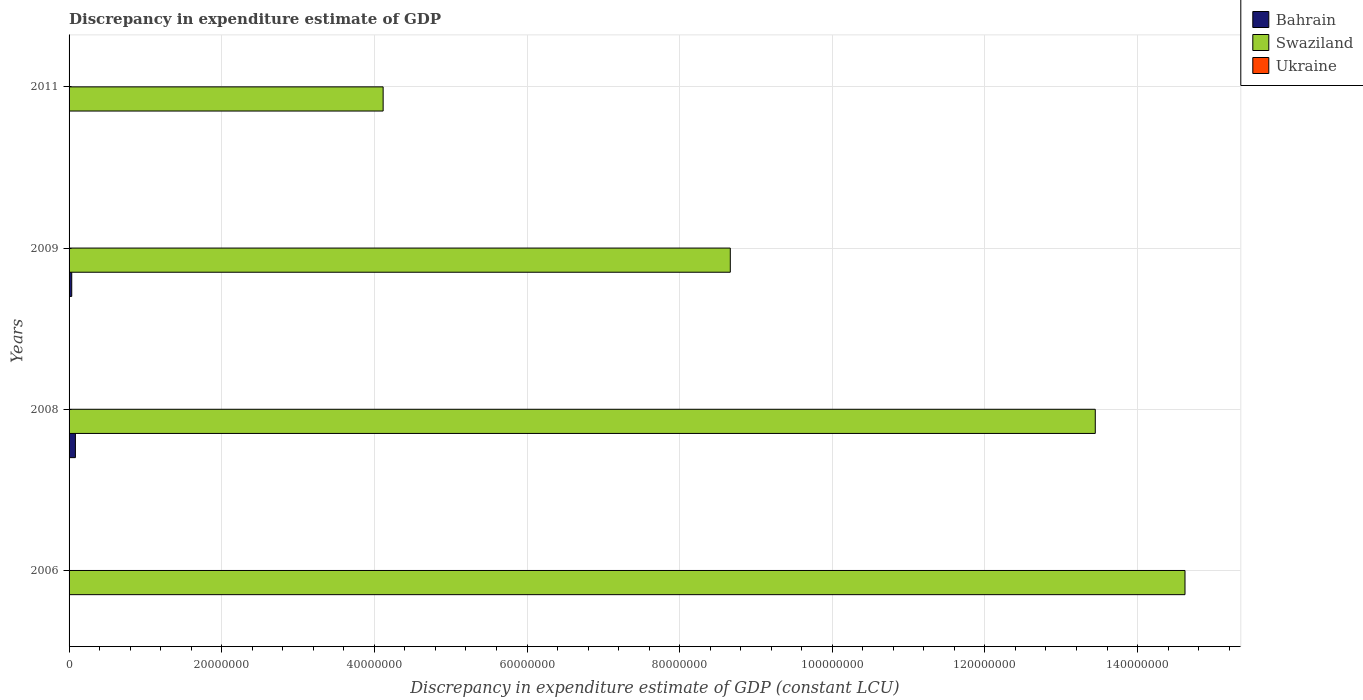How many groups of bars are there?
Your answer should be compact. 4. Are the number of bars on each tick of the Y-axis equal?
Your response must be concise. Yes. How many bars are there on the 3rd tick from the bottom?
Keep it short and to the point. 2. What is the label of the 4th group of bars from the top?
Provide a succinct answer. 2006. What is the discrepancy in expenditure estimate of GDP in Swaziland in 2006?
Make the answer very short. 1.46e+08. Across all years, what is the maximum discrepancy in expenditure estimate of GDP in Bahrain?
Your response must be concise. 8.30e+05. Across all years, what is the minimum discrepancy in expenditure estimate of GDP in Ukraine?
Ensure brevity in your answer.  0. In which year was the discrepancy in expenditure estimate of GDP in Bahrain maximum?
Your response must be concise. 2008. What is the total discrepancy in expenditure estimate of GDP in Swaziland in the graph?
Your answer should be very brief. 4.08e+08. What is the difference between the discrepancy in expenditure estimate of GDP in Swaziland in 2008 and that in 2011?
Your response must be concise. 9.33e+07. What is the difference between the discrepancy in expenditure estimate of GDP in Bahrain in 2006 and the discrepancy in expenditure estimate of GDP in Swaziland in 2011?
Provide a short and direct response. -4.11e+07. What is the average discrepancy in expenditure estimate of GDP in Swaziland per year?
Make the answer very short. 1.02e+08. In the year 2011, what is the difference between the discrepancy in expenditure estimate of GDP in Swaziland and discrepancy in expenditure estimate of GDP in Bahrain?
Your answer should be compact. 4.11e+07. What is the ratio of the discrepancy in expenditure estimate of GDP in Bahrain in 2008 to that in 2009?
Provide a succinct answer. 2.37. Is the discrepancy in expenditure estimate of GDP in Swaziland in 2009 less than that in 2011?
Offer a terse response. No. What is the difference between the highest and the second highest discrepancy in expenditure estimate of GDP in Swaziland?
Your answer should be very brief. 1.18e+07. Is the sum of the discrepancy in expenditure estimate of GDP in Bahrain in 2006 and 2008 greater than the maximum discrepancy in expenditure estimate of GDP in Ukraine across all years?
Your answer should be compact. Yes. Is it the case that in every year, the sum of the discrepancy in expenditure estimate of GDP in Bahrain and discrepancy in expenditure estimate of GDP in Ukraine is greater than the discrepancy in expenditure estimate of GDP in Swaziland?
Ensure brevity in your answer.  No. Are all the bars in the graph horizontal?
Ensure brevity in your answer.  Yes. How many years are there in the graph?
Keep it short and to the point. 4. What is the difference between two consecutive major ticks on the X-axis?
Ensure brevity in your answer.  2.00e+07. What is the title of the graph?
Provide a short and direct response. Discrepancy in expenditure estimate of GDP. What is the label or title of the X-axis?
Ensure brevity in your answer.  Discrepancy in expenditure estimate of GDP (constant LCU). What is the label or title of the Y-axis?
Your answer should be compact. Years. What is the Discrepancy in expenditure estimate of GDP (constant LCU) of Bahrain in 2006?
Provide a short and direct response. 10000. What is the Discrepancy in expenditure estimate of GDP (constant LCU) in Swaziland in 2006?
Provide a succinct answer. 1.46e+08. What is the Discrepancy in expenditure estimate of GDP (constant LCU) in Ukraine in 2006?
Make the answer very short. 0. What is the Discrepancy in expenditure estimate of GDP (constant LCU) in Bahrain in 2008?
Provide a succinct answer. 8.30e+05. What is the Discrepancy in expenditure estimate of GDP (constant LCU) of Swaziland in 2008?
Your answer should be very brief. 1.34e+08. What is the Discrepancy in expenditure estimate of GDP (constant LCU) in Swaziland in 2009?
Give a very brief answer. 8.66e+07. What is the Discrepancy in expenditure estimate of GDP (constant LCU) in Swaziland in 2011?
Your answer should be very brief. 4.12e+07. What is the Discrepancy in expenditure estimate of GDP (constant LCU) of Ukraine in 2011?
Ensure brevity in your answer.  0. Across all years, what is the maximum Discrepancy in expenditure estimate of GDP (constant LCU) of Bahrain?
Provide a succinct answer. 8.30e+05. Across all years, what is the maximum Discrepancy in expenditure estimate of GDP (constant LCU) in Swaziland?
Provide a short and direct response. 1.46e+08. Across all years, what is the minimum Discrepancy in expenditure estimate of GDP (constant LCU) in Swaziland?
Offer a very short reply. 4.12e+07. What is the total Discrepancy in expenditure estimate of GDP (constant LCU) in Bahrain in the graph?
Ensure brevity in your answer.  1.24e+06. What is the total Discrepancy in expenditure estimate of GDP (constant LCU) in Swaziland in the graph?
Offer a very short reply. 4.08e+08. What is the total Discrepancy in expenditure estimate of GDP (constant LCU) in Ukraine in the graph?
Make the answer very short. 0. What is the difference between the Discrepancy in expenditure estimate of GDP (constant LCU) in Bahrain in 2006 and that in 2008?
Offer a terse response. -8.20e+05. What is the difference between the Discrepancy in expenditure estimate of GDP (constant LCU) in Swaziland in 2006 and that in 2008?
Give a very brief answer. 1.18e+07. What is the difference between the Discrepancy in expenditure estimate of GDP (constant LCU) in Bahrain in 2006 and that in 2009?
Offer a terse response. -3.40e+05. What is the difference between the Discrepancy in expenditure estimate of GDP (constant LCU) in Swaziland in 2006 and that in 2009?
Ensure brevity in your answer.  5.96e+07. What is the difference between the Discrepancy in expenditure estimate of GDP (constant LCU) in Swaziland in 2006 and that in 2011?
Provide a succinct answer. 1.05e+08. What is the difference between the Discrepancy in expenditure estimate of GDP (constant LCU) in Bahrain in 2008 and that in 2009?
Provide a succinct answer. 4.80e+05. What is the difference between the Discrepancy in expenditure estimate of GDP (constant LCU) of Swaziland in 2008 and that in 2009?
Offer a terse response. 4.78e+07. What is the difference between the Discrepancy in expenditure estimate of GDP (constant LCU) of Bahrain in 2008 and that in 2011?
Keep it short and to the point. 7.80e+05. What is the difference between the Discrepancy in expenditure estimate of GDP (constant LCU) in Swaziland in 2008 and that in 2011?
Your answer should be very brief. 9.33e+07. What is the difference between the Discrepancy in expenditure estimate of GDP (constant LCU) in Swaziland in 2009 and that in 2011?
Your answer should be compact. 4.55e+07. What is the difference between the Discrepancy in expenditure estimate of GDP (constant LCU) of Bahrain in 2006 and the Discrepancy in expenditure estimate of GDP (constant LCU) of Swaziland in 2008?
Your answer should be compact. -1.34e+08. What is the difference between the Discrepancy in expenditure estimate of GDP (constant LCU) of Bahrain in 2006 and the Discrepancy in expenditure estimate of GDP (constant LCU) of Swaziland in 2009?
Give a very brief answer. -8.66e+07. What is the difference between the Discrepancy in expenditure estimate of GDP (constant LCU) of Bahrain in 2006 and the Discrepancy in expenditure estimate of GDP (constant LCU) of Swaziland in 2011?
Ensure brevity in your answer.  -4.11e+07. What is the difference between the Discrepancy in expenditure estimate of GDP (constant LCU) in Bahrain in 2008 and the Discrepancy in expenditure estimate of GDP (constant LCU) in Swaziland in 2009?
Your answer should be very brief. -8.58e+07. What is the difference between the Discrepancy in expenditure estimate of GDP (constant LCU) in Bahrain in 2008 and the Discrepancy in expenditure estimate of GDP (constant LCU) in Swaziland in 2011?
Offer a terse response. -4.03e+07. What is the difference between the Discrepancy in expenditure estimate of GDP (constant LCU) in Bahrain in 2009 and the Discrepancy in expenditure estimate of GDP (constant LCU) in Swaziland in 2011?
Your response must be concise. -4.08e+07. What is the average Discrepancy in expenditure estimate of GDP (constant LCU) in Bahrain per year?
Offer a very short reply. 3.10e+05. What is the average Discrepancy in expenditure estimate of GDP (constant LCU) in Swaziland per year?
Give a very brief answer. 1.02e+08. In the year 2006, what is the difference between the Discrepancy in expenditure estimate of GDP (constant LCU) in Bahrain and Discrepancy in expenditure estimate of GDP (constant LCU) in Swaziland?
Keep it short and to the point. -1.46e+08. In the year 2008, what is the difference between the Discrepancy in expenditure estimate of GDP (constant LCU) of Bahrain and Discrepancy in expenditure estimate of GDP (constant LCU) of Swaziland?
Offer a very short reply. -1.34e+08. In the year 2009, what is the difference between the Discrepancy in expenditure estimate of GDP (constant LCU) in Bahrain and Discrepancy in expenditure estimate of GDP (constant LCU) in Swaziland?
Your answer should be compact. -8.63e+07. In the year 2011, what is the difference between the Discrepancy in expenditure estimate of GDP (constant LCU) in Bahrain and Discrepancy in expenditure estimate of GDP (constant LCU) in Swaziland?
Your answer should be very brief. -4.11e+07. What is the ratio of the Discrepancy in expenditure estimate of GDP (constant LCU) of Bahrain in 2006 to that in 2008?
Provide a short and direct response. 0.01. What is the ratio of the Discrepancy in expenditure estimate of GDP (constant LCU) of Swaziland in 2006 to that in 2008?
Provide a short and direct response. 1.09. What is the ratio of the Discrepancy in expenditure estimate of GDP (constant LCU) in Bahrain in 2006 to that in 2009?
Ensure brevity in your answer.  0.03. What is the ratio of the Discrepancy in expenditure estimate of GDP (constant LCU) in Swaziland in 2006 to that in 2009?
Your answer should be very brief. 1.69. What is the ratio of the Discrepancy in expenditure estimate of GDP (constant LCU) of Swaziland in 2006 to that in 2011?
Keep it short and to the point. 3.55. What is the ratio of the Discrepancy in expenditure estimate of GDP (constant LCU) of Bahrain in 2008 to that in 2009?
Your response must be concise. 2.37. What is the ratio of the Discrepancy in expenditure estimate of GDP (constant LCU) in Swaziland in 2008 to that in 2009?
Keep it short and to the point. 1.55. What is the ratio of the Discrepancy in expenditure estimate of GDP (constant LCU) of Swaziland in 2008 to that in 2011?
Make the answer very short. 3.27. What is the ratio of the Discrepancy in expenditure estimate of GDP (constant LCU) of Bahrain in 2009 to that in 2011?
Your answer should be very brief. 7. What is the ratio of the Discrepancy in expenditure estimate of GDP (constant LCU) of Swaziland in 2009 to that in 2011?
Provide a short and direct response. 2.11. What is the difference between the highest and the second highest Discrepancy in expenditure estimate of GDP (constant LCU) in Swaziland?
Make the answer very short. 1.18e+07. What is the difference between the highest and the lowest Discrepancy in expenditure estimate of GDP (constant LCU) of Bahrain?
Ensure brevity in your answer.  8.20e+05. What is the difference between the highest and the lowest Discrepancy in expenditure estimate of GDP (constant LCU) of Swaziland?
Offer a very short reply. 1.05e+08. 